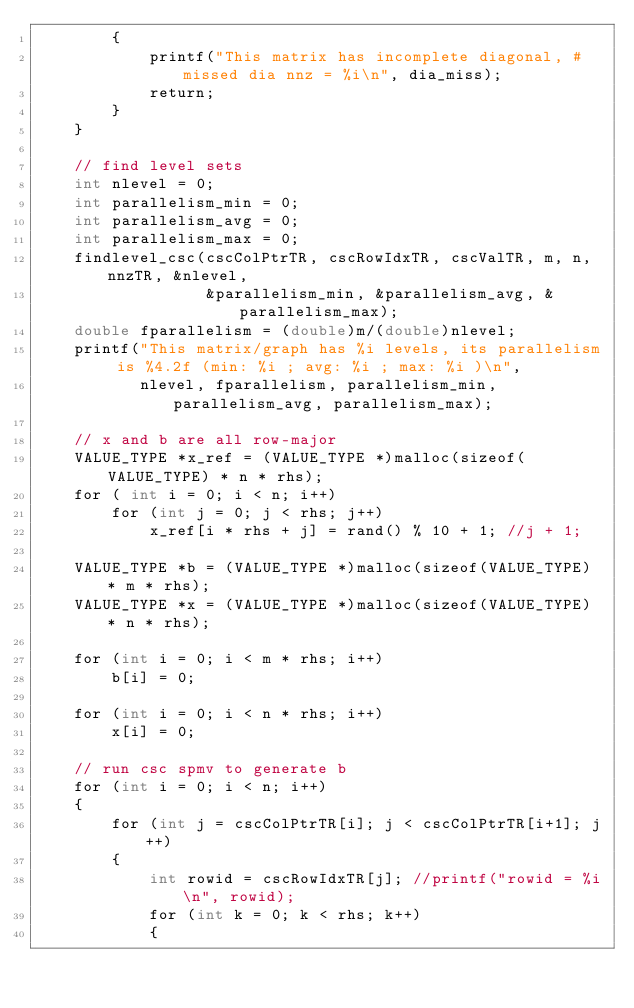Convert code to text. <code><loc_0><loc_0><loc_500><loc_500><_Cuda_>        {
            printf("This matrix has incomplete diagonal, #missed dia nnz = %i\n", dia_miss); 
            return;
        }
    }

    // find level sets
    int nlevel = 0;
    int parallelism_min = 0;
    int parallelism_avg = 0;
    int parallelism_max = 0;
    findlevel_csc(cscColPtrTR, cscRowIdxTR, cscValTR, m, n, nnzTR, &nlevel,
                  &parallelism_min, &parallelism_avg, &parallelism_max);
    double fparallelism = (double)m/(double)nlevel;
    printf("This matrix/graph has %i levels, its parallelism is %4.2f (min: %i ; avg: %i ; max: %i )\n", 
           nlevel, fparallelism, parallelism_min, parallelism_avg, parallelism_max);

    // x and b are all row-major
    VALUE_TYPE *x_ref = (VALUE_TYPE *)malloc(sizeof(VALUE_TYPE) * n * rhs);
    for ( int i = 0; i < n; i++)
        for (int j = 0; j < rhs; j++)
            x_ref[i * rhs + j] = rand() % 10 + 1; //j + 1;

    VALUE_TYPE *b = (VALUE_TYPE *)malloc(sizeof(VALUE_TYPE) * m * rhs);
    VALUE_TYPE *x = (VALUE_TYPE *)malloc(sizeof(VALUE_TYPE) * n * rhs);

    for (int i = 0; i < m * rhs; i++)
        b[i] = 0;

    for (int i = 0; i < n * rhs; i++)
        x[i] = 0;

    // run csc spmv to generate b
    for (int i = 0; i < n; i++)
    {
        for (int j = cscColPtrTR[i]; j < cscColPtrTR[i+1]; j++)
        {
            int rowid = cscRowIdxTR[j]; //printf("rowid = %i\n", rowid);
            for (int k = 0; k < rhs; k++)
            {</code> 